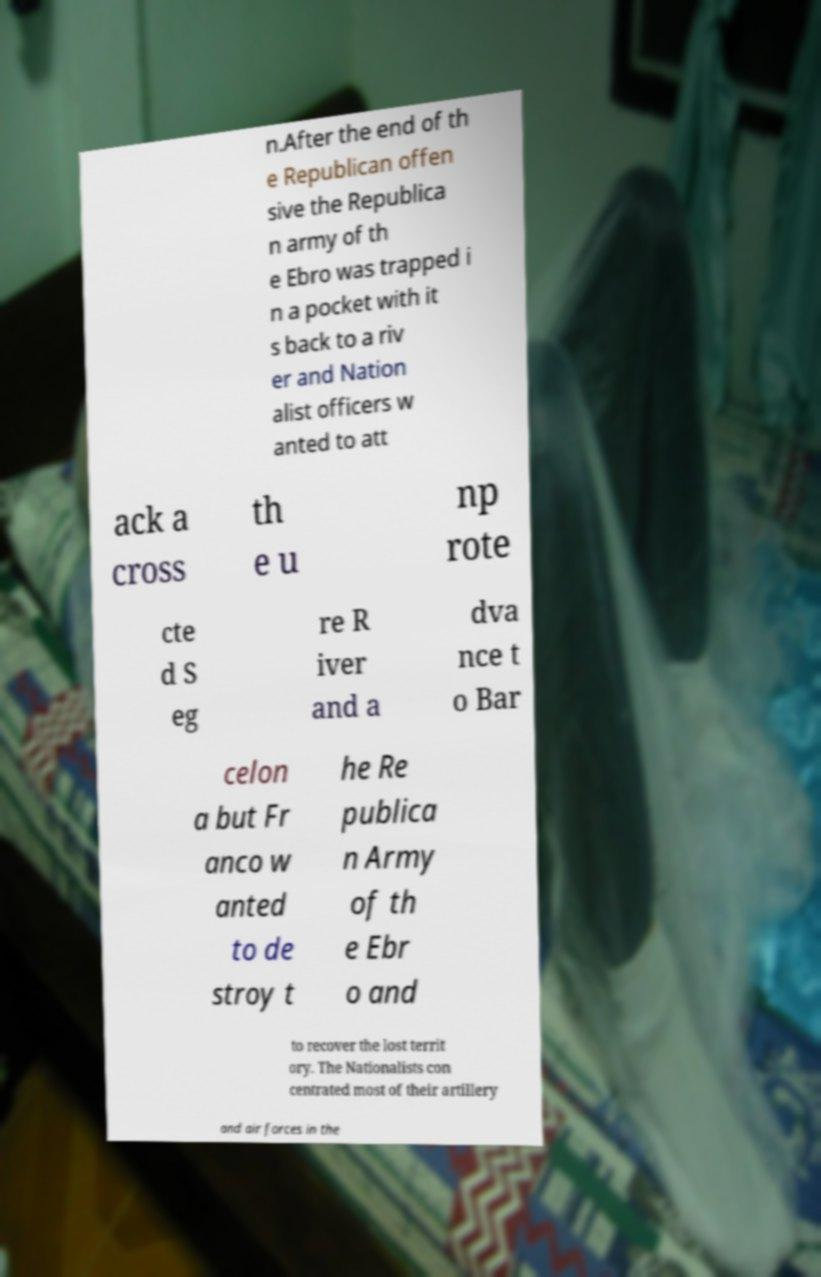Could you extract and type out the text from this image? n.After the end of th e Republican offen sive the Republica n army of th e Ebro was trapped i n a pocket with it s back to a riv er and Nation alist officers w anted to att ack a cross th e u np rote cte d S eg re R iver and a dva nce t o Bar celon a but Fr anco w anted to de stroy t he Re publica n Army of th e Ebr o and to recover the lost territ ory. The Nationalists con centrated most of their artillery and air forces in the 